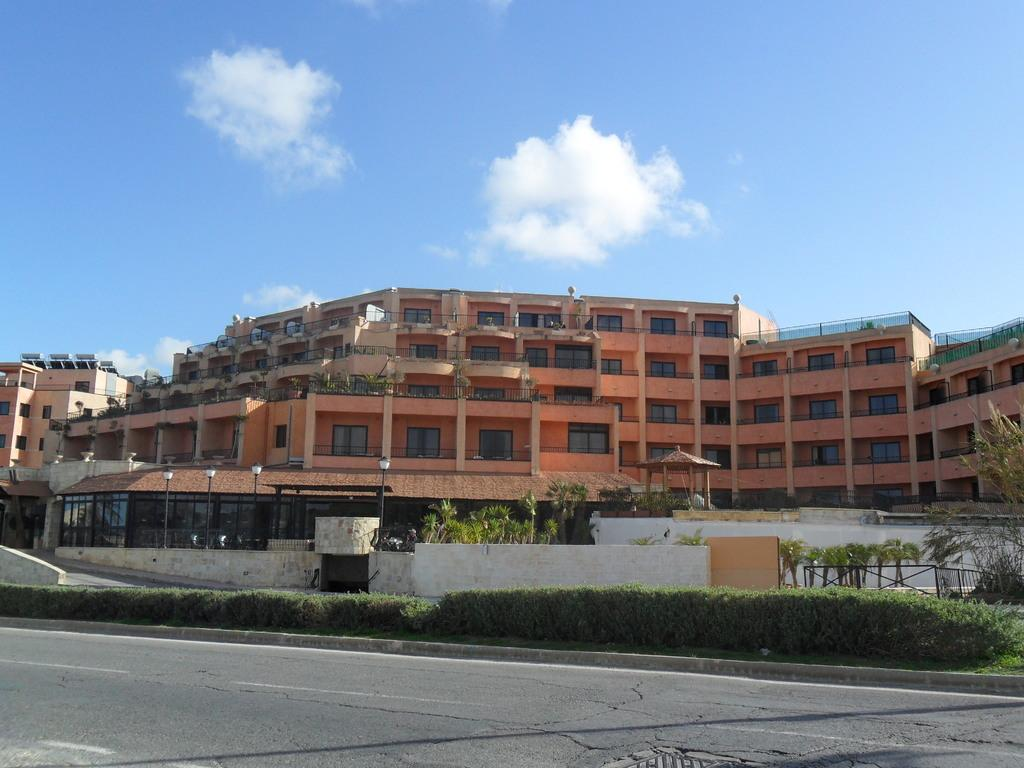What type of vegetation can be seen in the image? There are bushes in the image. What type of lighting is present in the image? There are street lamps in the image. What is located in the middle of the image? There is a road in the middle of the image. What can be seen in the background of the image? There are buildings in the background of the image. What is visible at the top of the image? The sky is visible at the top of the image. What type of jeans is the person wearing at the meeting in the image? There is no person or meeting present in the image; it features bushes, street lamps, a road, buildings, and the sky. What is the home like in the image? There is no home present in the image; it features bushes, street lamps, a road, buildings, and the sky. 